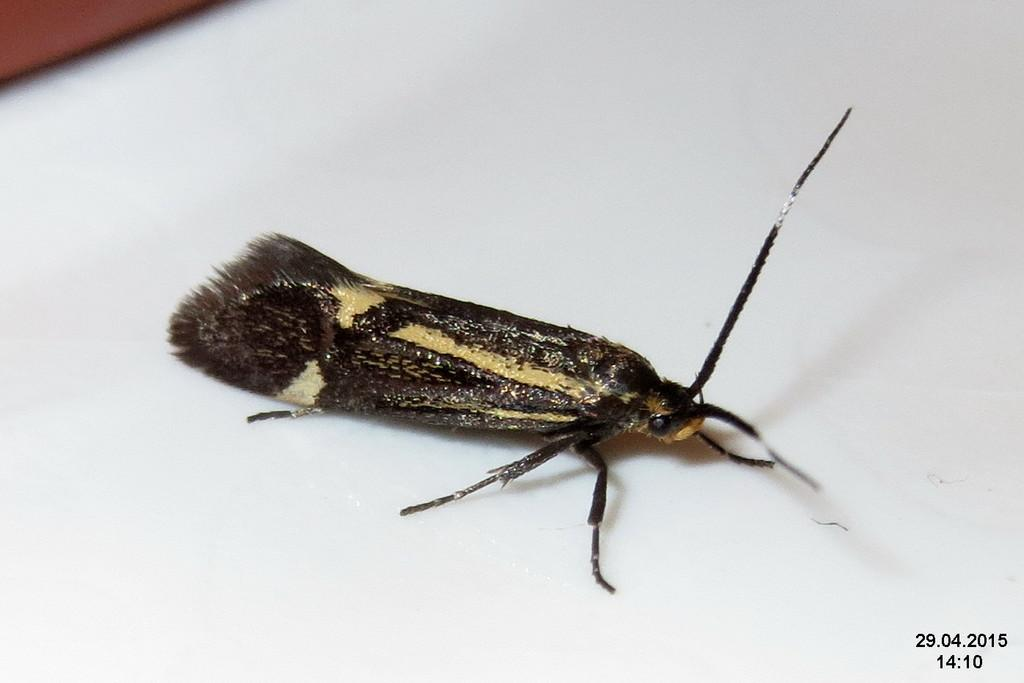What type of creature is present in the image? There is an insect in the image. Where is the insect located in the image? The insect is on a surface. What type of business is being conducted by the insect in the image? There is no indication of any business being conducted in the image, as it features an insect on a surface. 